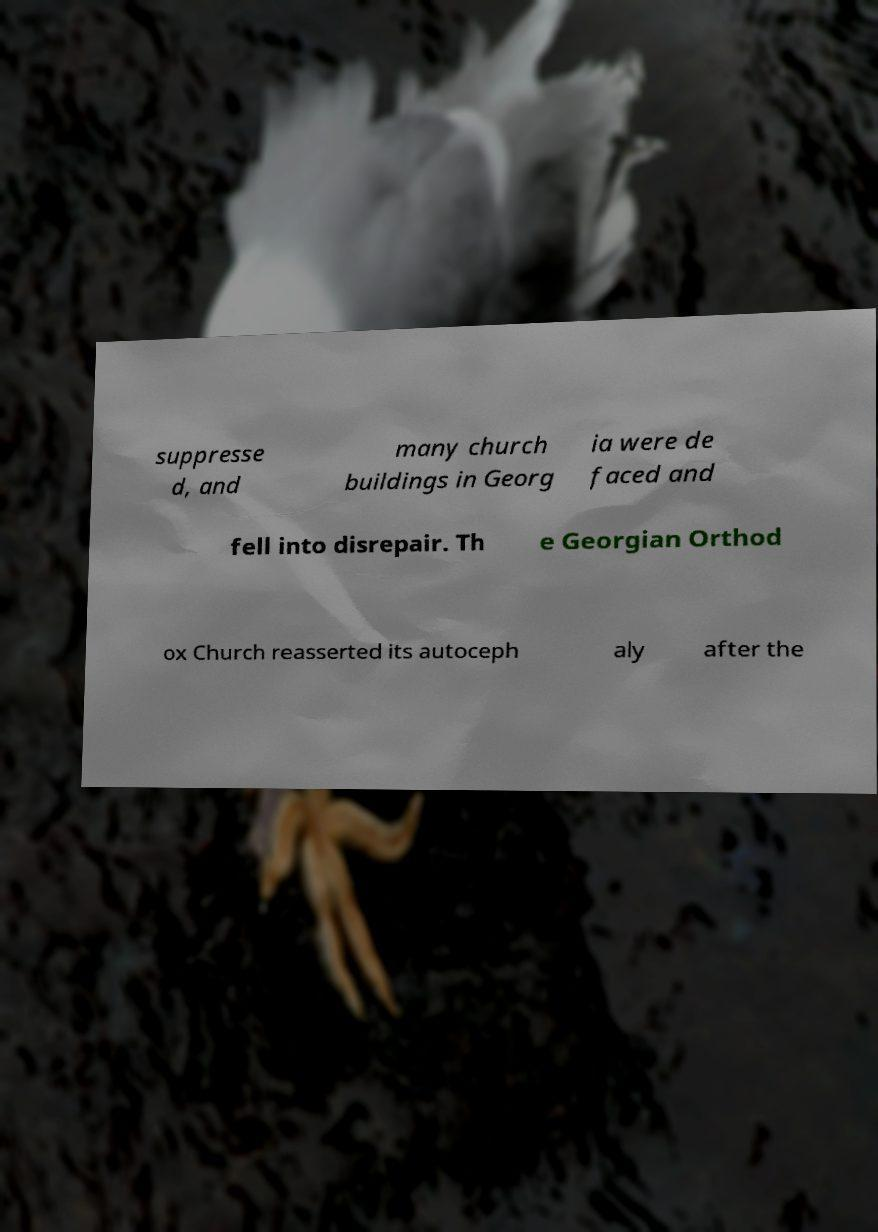Can you read and provide the text displayed in the image?This photo seems to have some interesting text. Can you extract and type it out for me? suppresse d, and many church buildings in Georg ia were de faced and fell into disrepair. Th e Georgian Orthod ox Church reasserted its autoceph aly after the 